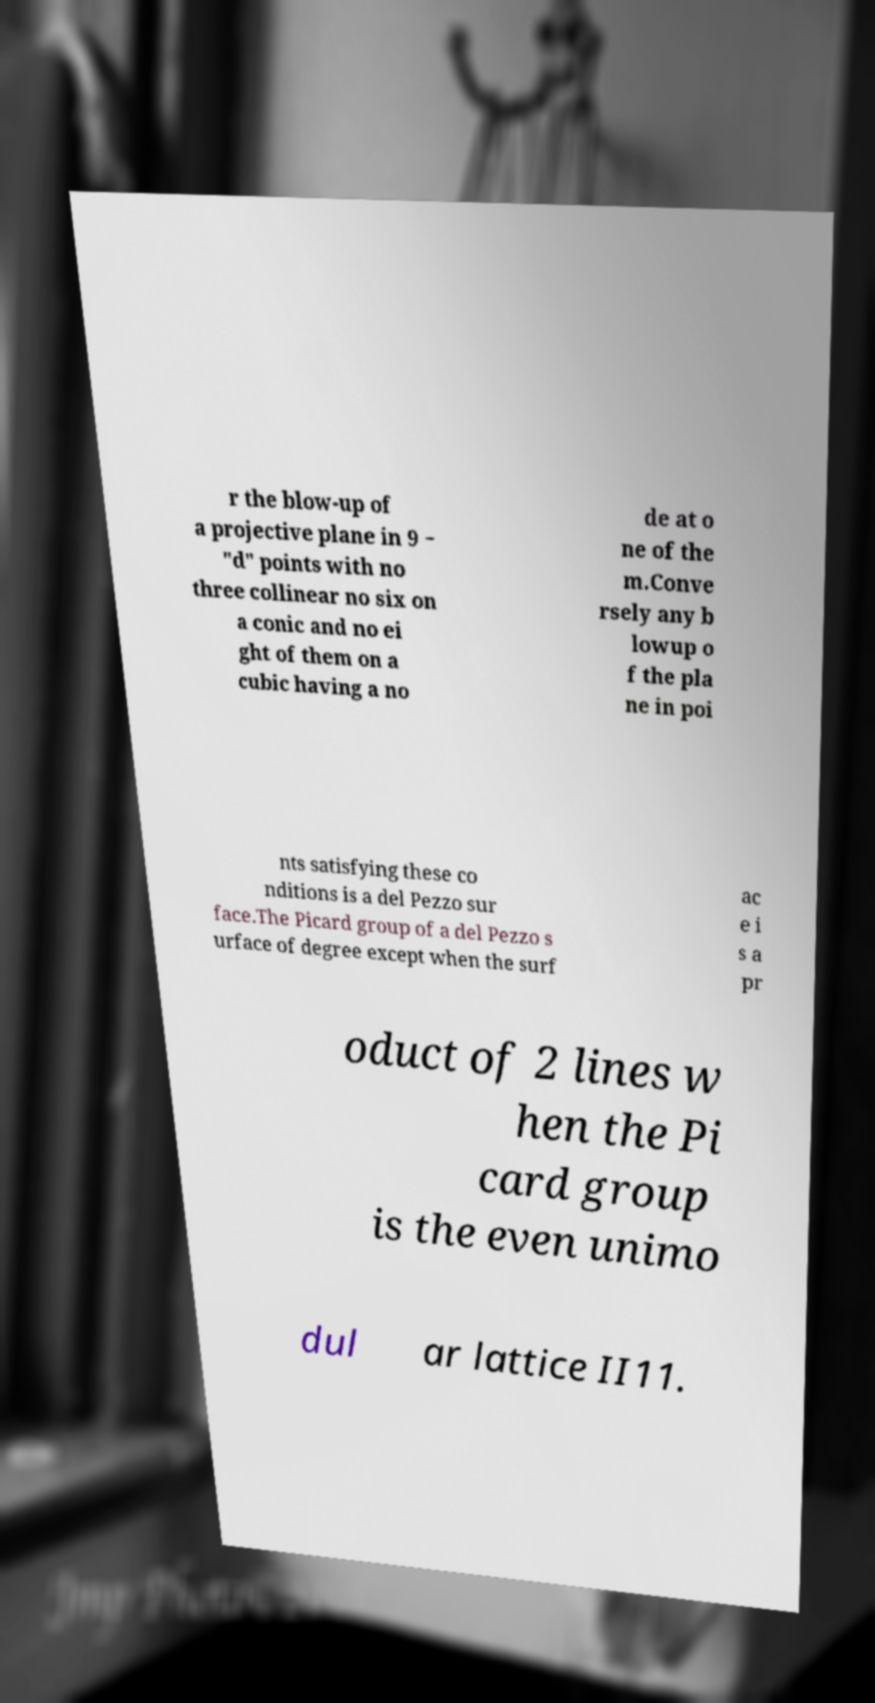For documentation purposes, I need the text within this image transcribed. Could you provide that? r the blow-up of a projective plane in 9 − "d" points with no three collinear no six on a conic and no ei ght of them on a cubic having a no de at o ne of the m.Conve rsely any b lowup o f the pla ne in poi nts satisfying these co nditions is a del Pezzo sur face.The Picard group of a del Pezzo s urface of degree except when the surf ac e i s a pr oduct of 2 lines w hen the Pi card group is the even unimo dul ar lattice II11. 